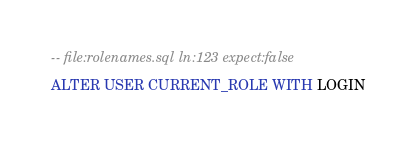<code> <loc_0><loc_0><loc_500><loc_500><_SQL_>-- file:rolenames.sql ln:123 expect:false
ALTER USER CURRENT_ROLE WITH LOGIN
</code> 